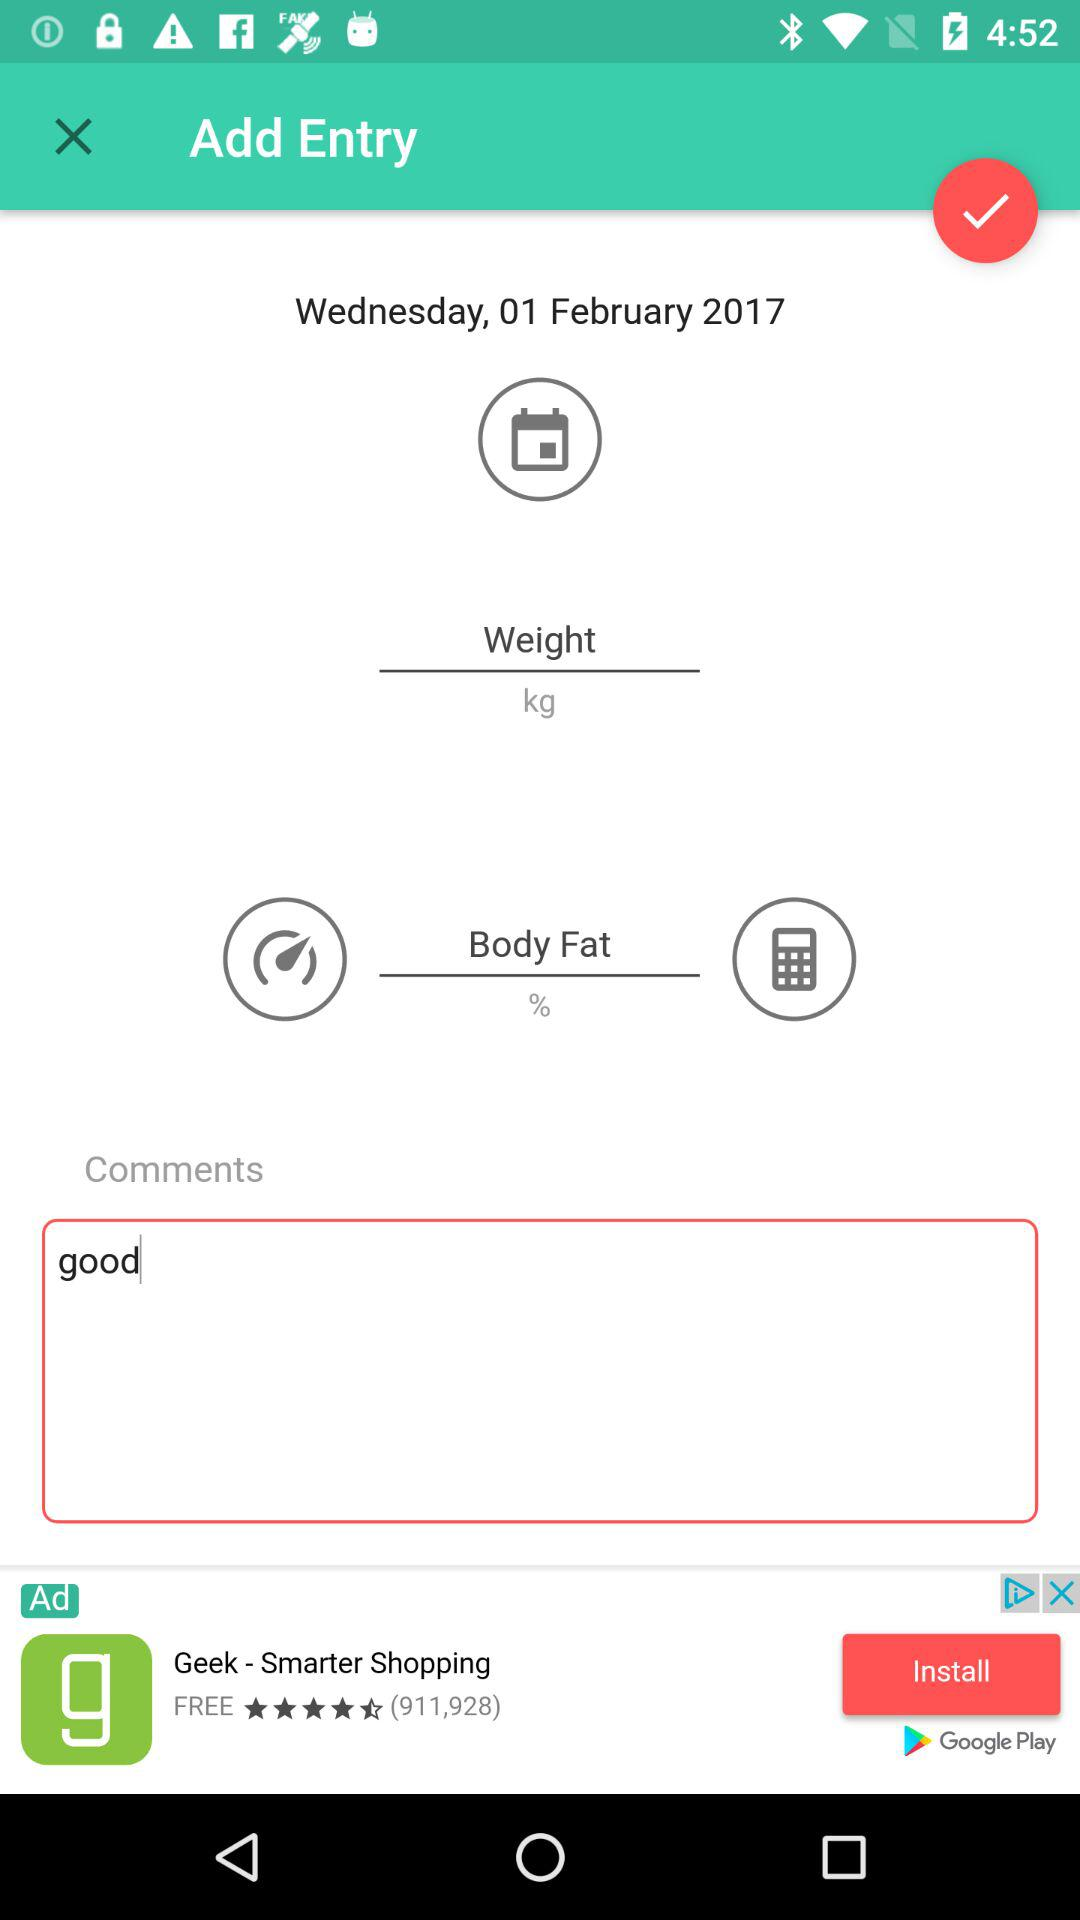What was written in the comment section? In the comment section, the "good" was written. 